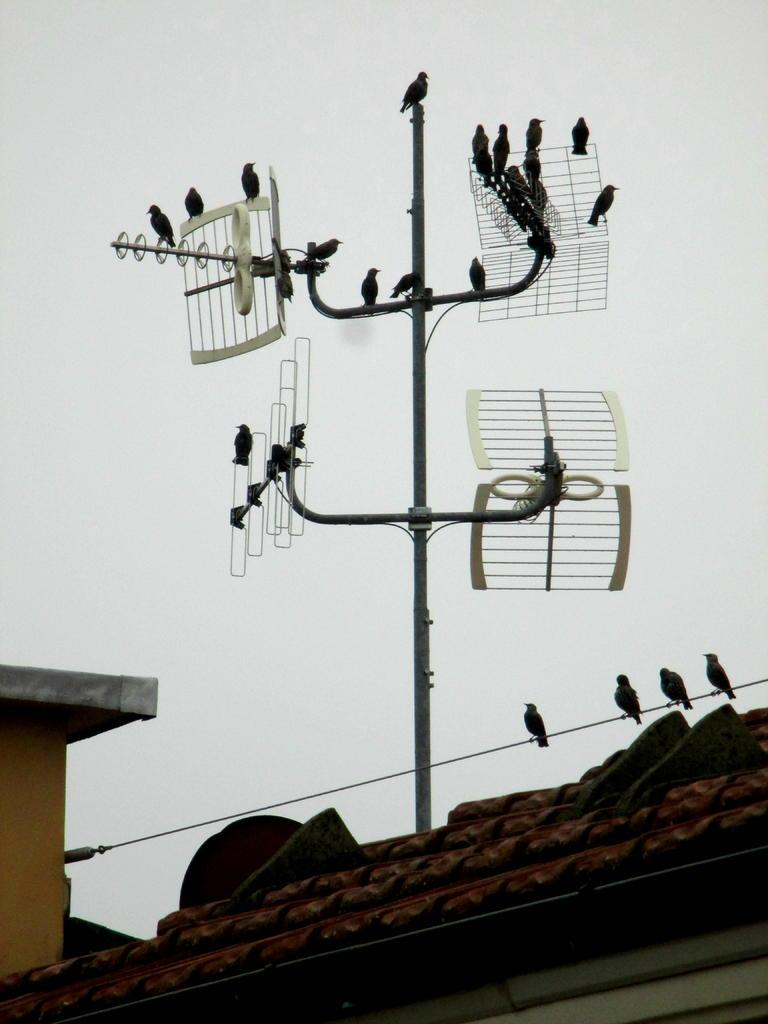What is the main subject of the image? The main subject of the image is many birds. Where are the birds located in the image? The birds are on a pole and wire in the image. What structure is visible at the bottom of the image? The roof of a building is visible at the bottom of the image. What is visible at the top of the image? The sky is visible at the top of the image. What type of spoon can be seen in the image? There is no spoon present in the image. How many tomatoes are on the pole with the birds? There are no tomatoes present in the image; only birds are visible on the pole and wire. 